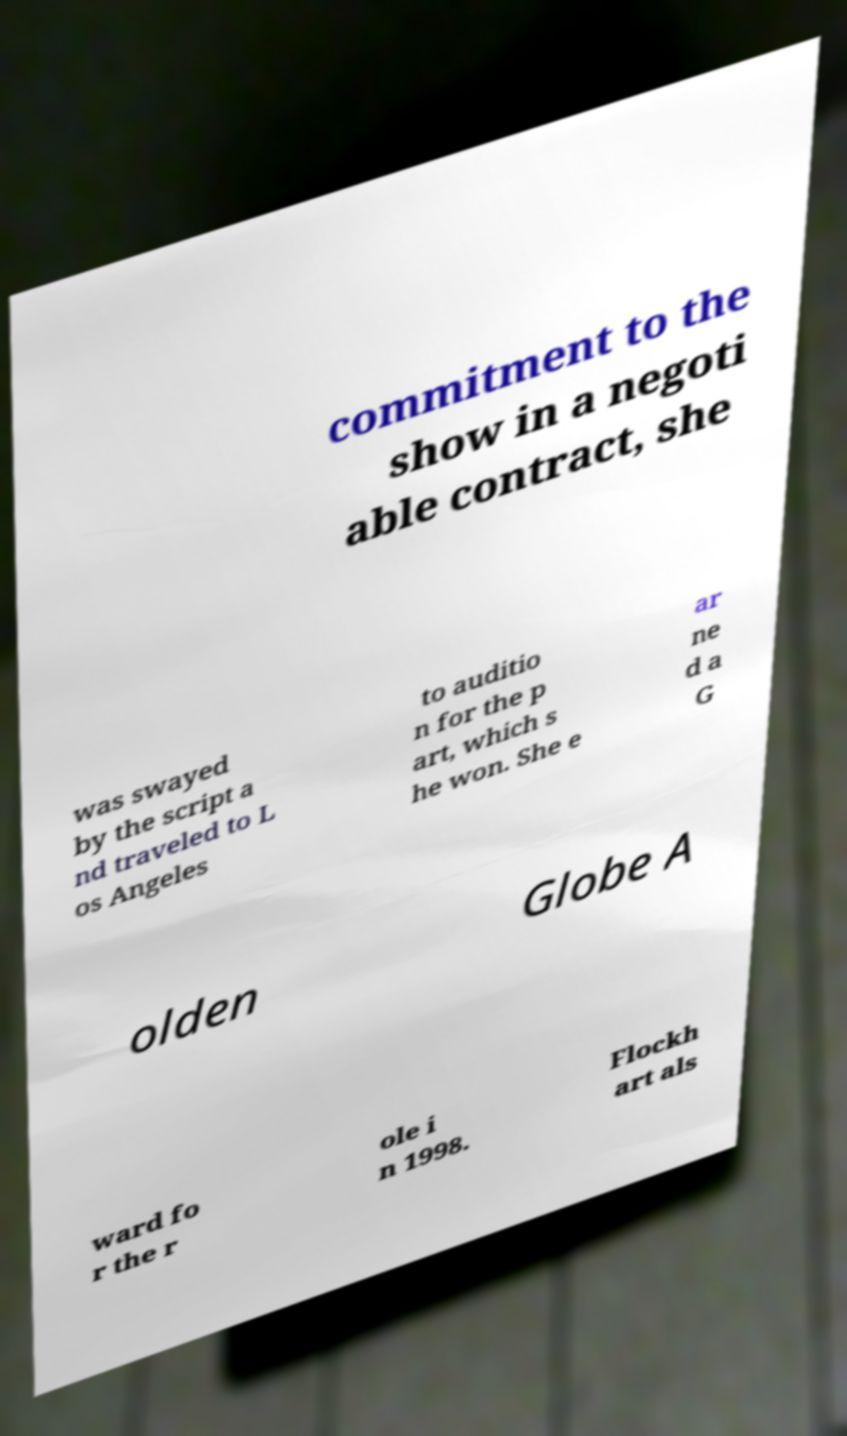What messages or text are displayed in this image? I need them in a readable, typed format. commitment to the show in a negoti able contract, she was swayed by the script a nd traveled to L os Angeles to auditio n for the p art, which s he won. She e ar ne d a G olden Globe A ward fo r the r ole i n 1998. Flockh art als 